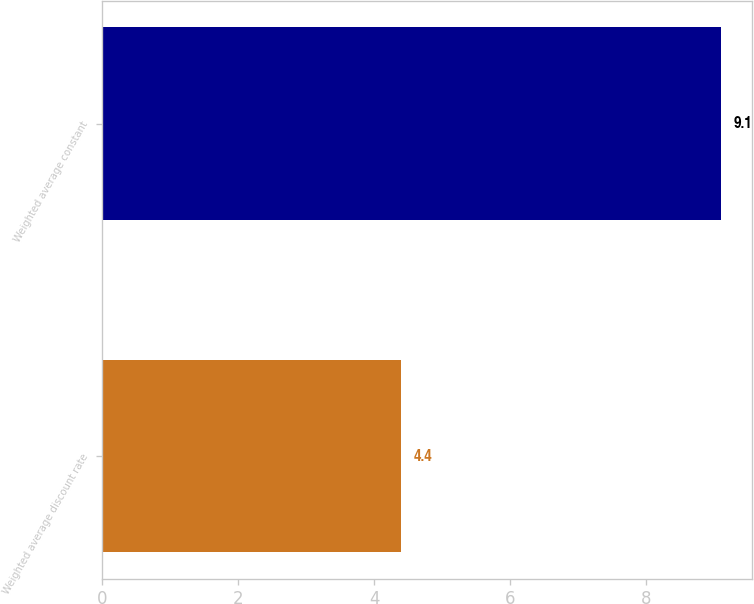Convert chart to OTSL. <chart><loc_0><loc_0><loc_500><loc_500><bar_chart><fcel>Weighted average discount rate<fcel>Weighted average constant<nl><fcel>4.4<fcel>9.1<nl></chart> 